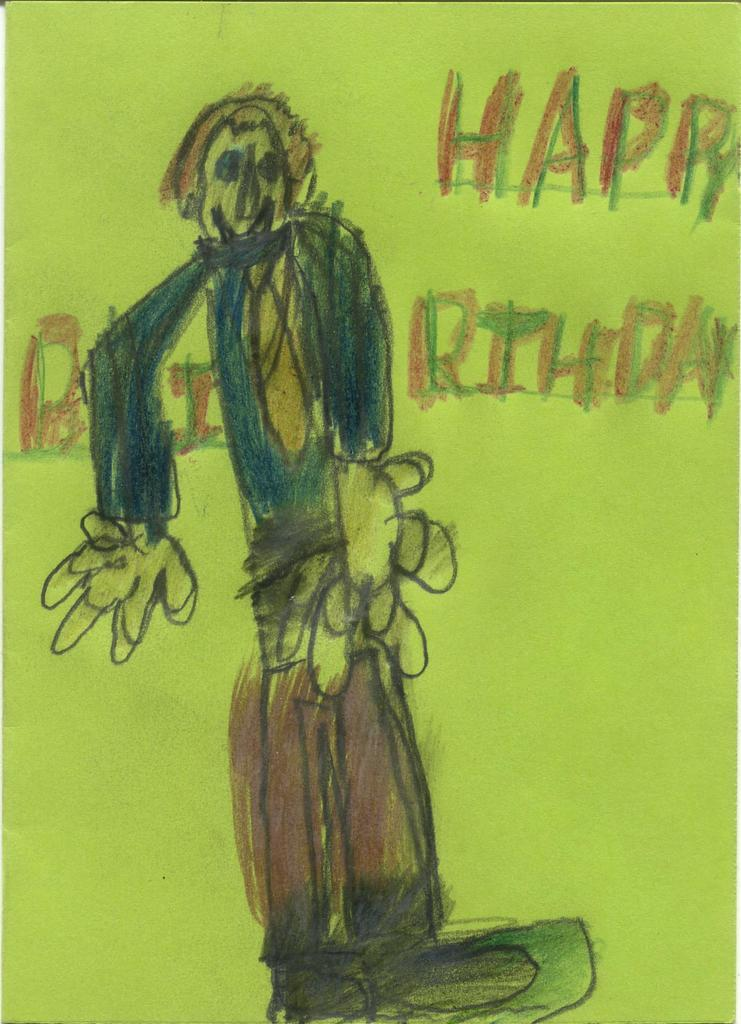What is depicted on the paper in the image? There is a sketch of a person in the image. What else can be seen on the paper besides the sketch? There is text on the paper in the image. Where is the nest located in the image? There is no nest present in the image. What type of clam is shown in the image? There is no clam present in the image. 